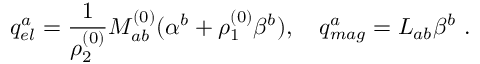Convert formula to latex. <formula><loc_0><loc_0><loc_500><loc_500>q _ { e l } ^ { a } = { \frac { 1 } { \rho _ { 2 } ^ { ( 0 ) } } } M _ { a b } ^ { ( 0 ) } ( \alpha ^ { b } + \rho _ { 1 } ^ { ( 0 ) } \beta ^ { b } ) , \quad q _ { m a g } ^ { a } = L _ { a b } \beta ^ { b } .</formula> 